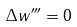Convert formula to latex. <formula><loc_0><loc_0><loc_500><loc_500>\Delta w ^ { \prime \prime \prime } = 0</formula> 